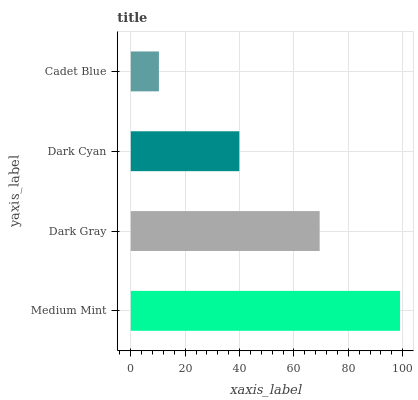Is Cadet Blue the minimum?
Answer yes or no. Yes. Is Medium Mint the maximum?
Answer yes or no. Yes. Is Dark Gray the minimum?
Answer yes or no. No. Is Dark Gray the maximum?
Answer yes or no. No. Is Medium Mint greater than Dark Gray?
Answer yes or no. Yes. Is Dark Gray less than Medium Mint?
Answer yes or no. Yes. Is Dark Gray greater than Medium Mint?
Answer yes or no. No. Is Medium Mint less than Dark Gray?
Answer yes or no. No. Is Dark Gray the high median?
Answer yes or no. Yes. Is Dark Cyan the low median?
Answer yes or no. Yes. Is Cadet Blue the high median?
Answer yes or no. No. Is Medium Mint the low median?
Answer yes or no. No. 